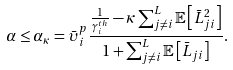Convert formula to latex. <formula><loc_0><loc_0><loc_500><loc_500>\alpha \leq \alpha _ { \kappa } = \bar { \upsilon } _ { i } ^ { p } \frac { \frac { 1 } { \gamma _ { i } ^ { t h } } - \kappa \sum _ { j \neq i } ^ { L } \mathbb { E } \left [ \bar { L } _ { j i } ^ { 2 } \right ] } { 1 + \sum _ { j \neq i } ^ { L } \mathbb { E } \left [ \bar { L } _ { j i } \right ] } .</formula> 